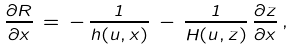<formula> <loc_0><loc_0><loc_500><loc_500>\frac { \partial R } { \partial x } \, = \, - \, \frac { 1 } { h ( u , x ) } \, - \, \frac { 1 } { H ( u , z ) } \, \frac { \partial z } { \partial x } \, ,</formula> 